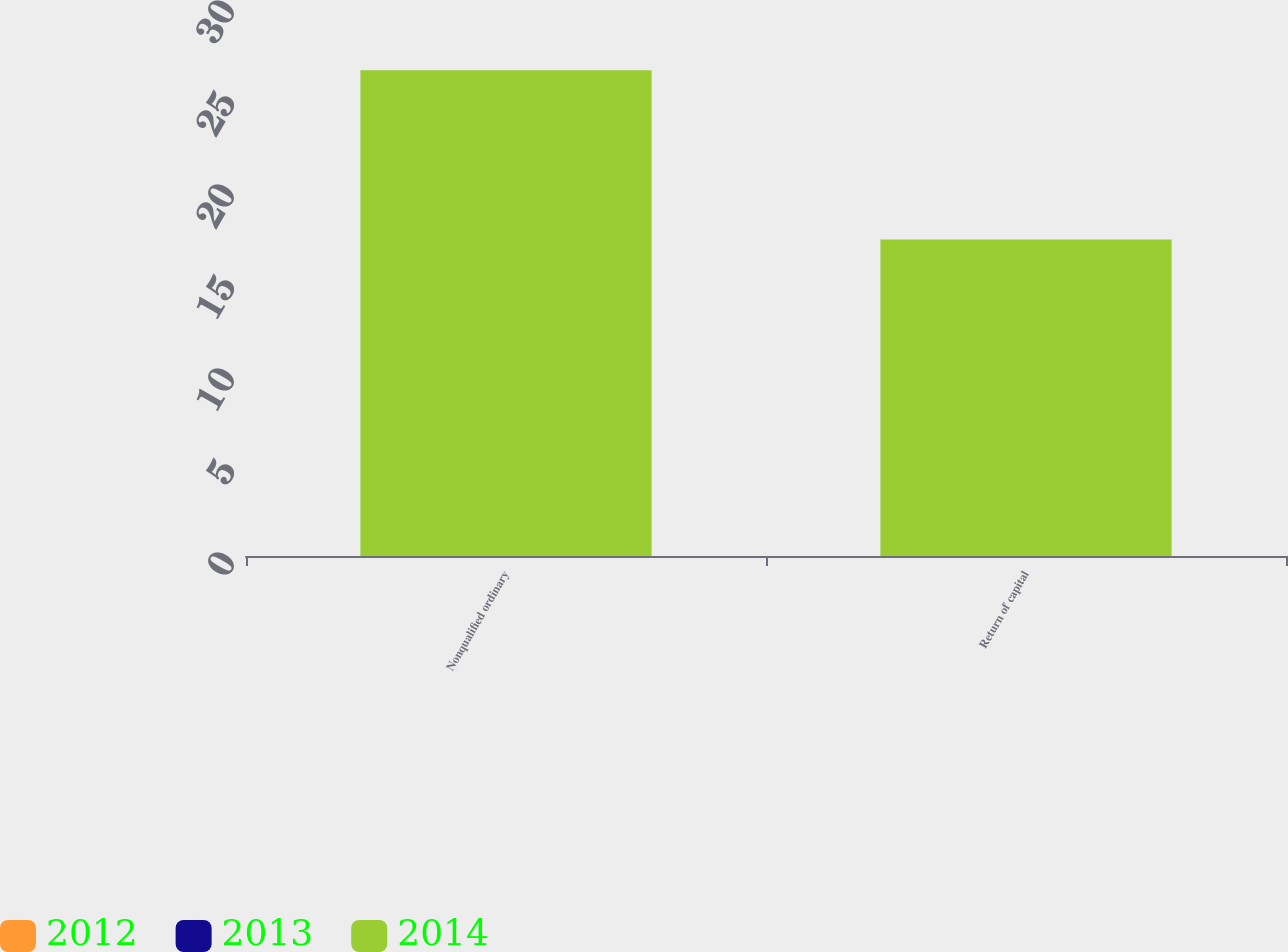Convert chart to OTSL. <chart><loc_0><loc_0><loc_500><loc_500><stacked_bar_chart><ecel><fcel>Nonqualified ordinary<fcel>Return of capital<nl><fcel>2012<fcel>0<fcel>0<nl><fcel>2013<fcel>0<fcel>0<nl><fcel>2014<fcel>26.4<fcel>17.2<nl></chart> 